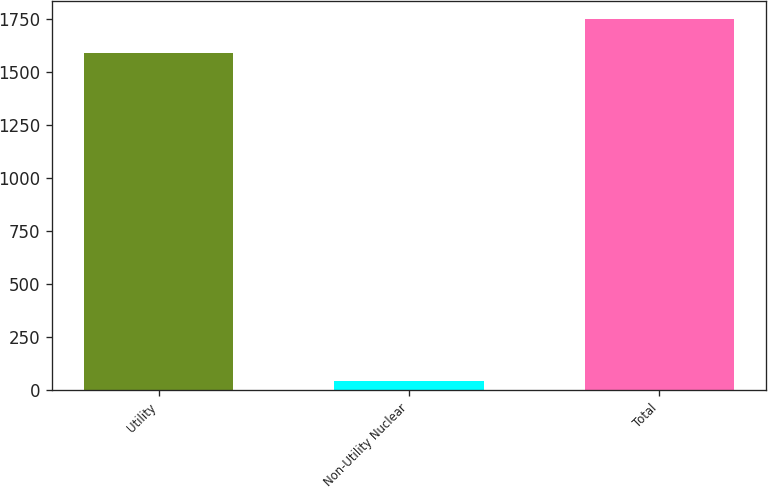<chart> <loc_0><loc_0><loc_500><loc_500><bar_chart><fcel>Utility<fcel>Non-Utility Nuclear<fcel>Total<nl><fcel>1590<fcel>41<fcel>1749<nl></chart> 